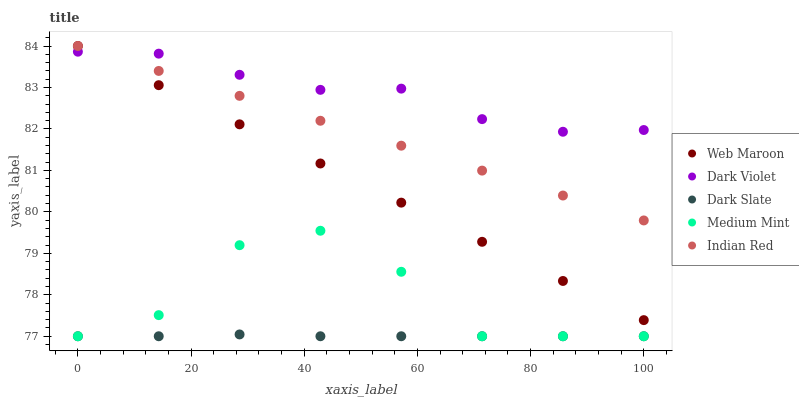Does Dark Slate have the minimum area under the curve?
Answer yes or no. Yes. Does Dark Violet have the maximum area under the curve?
Answer yes or no. Yes. Does Web Maroon have the minimum area under the curve?
Answer yes or no. No. Does Web Maroon have the maximum area under the curve?
Answer yes or no. No. Is Web Maroon the smoothest?
Answer yes or no. Yes. Is Medium Mint the roughest?
Answer yes or no. Yes. Is Dark Slate the smoothest?
Answer yes or no. No. Is Dark Slate the roughest?
Answer yes or no. No. Does Medium Mint have the lowest value?
Answer yes or no. Yes. Does Web Maroon have the lowest value?
Answer yes or no. No. Does Indian Red have the highest value?
Answer yes or no. Yes. Does Dark Slate have the highest value?
Answer yes or no. No. Is Medium Mint less than Indian Red?
Answer yes or no. Yes. Is Web Maroon greater than Medium Mint?
Answer yes or no. Yes. Does Web Maroon intersect Dark Violet?
Answer yes or no. Yes. Is Web Maroon less than Dark Violet?
Answer yes or no. No. Is Web Maroon greater than Dark Violet?
Answer yes or no. No. Does Medium Mint intersect Indian Red?
Answer yes or no. No. 